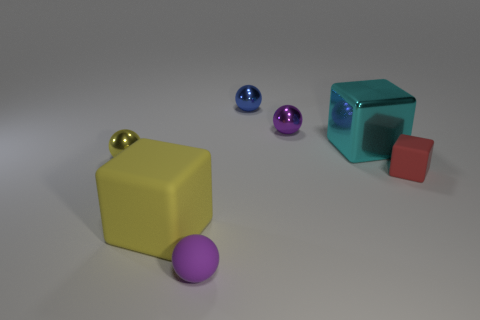Could you tell me more about the colors of the objects in this image? Certainly! The objects display a variety of vibrant colors such as yellow, purple, red, cyan, and blue. Each color seems to be carefully chosen to create a visually pleasing contrast and to highlight the reflective properties of the objects' materials. 